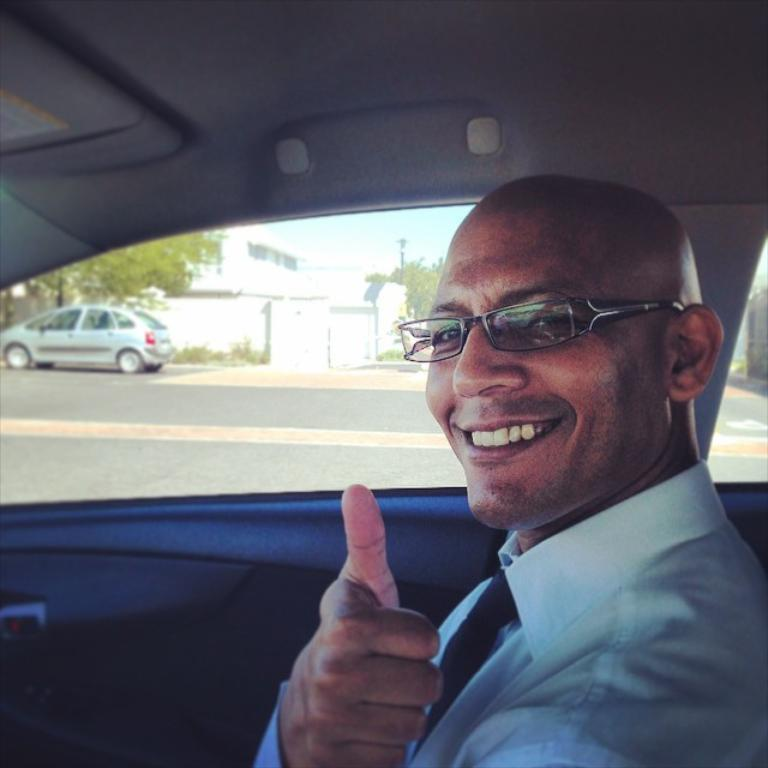What is the person in the image doing? The person is smiling and showing their thumb in the image. Where is the person located in the image? The person is sitting in a car in the image. What can be seen behind the person's car? There is another car behind the person's car in the image. What type of vegetation is visible in the image? There is a tree visible in the image. What type of structure can be seen in the image? There is a building in the image. What type of leather material is covering the person's hand in the image? There is no leather material visible on the person's hand in the image; they are simply showing their thumb while smiling. 